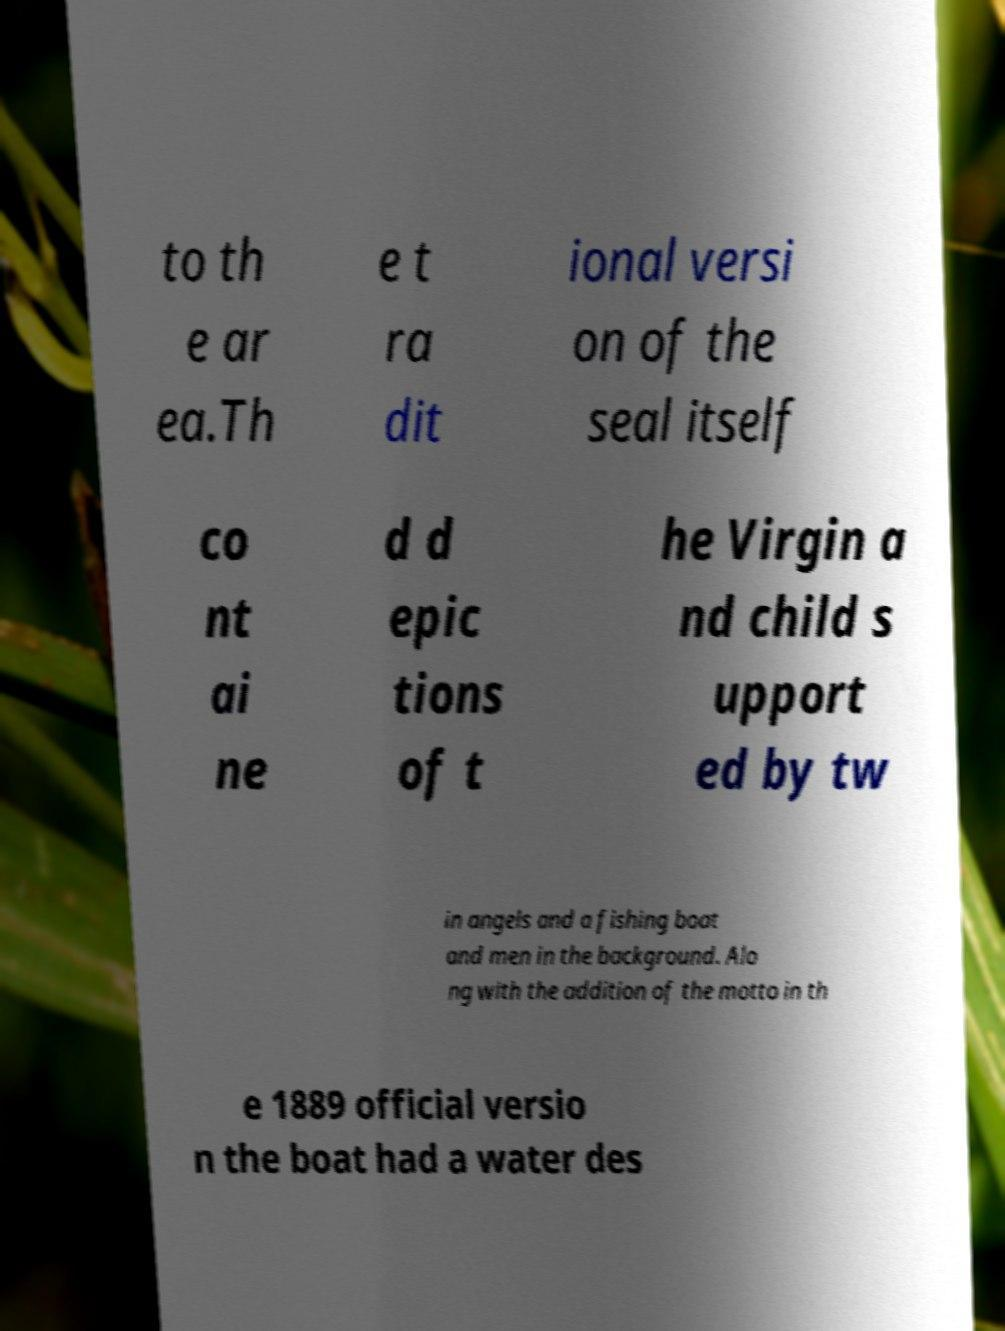Could you assist in decoding the text presented in this image and type it out clearly? to th e ar ea.Th e t ra dit ional versi on of the seal itself co nt ai ne d d epic tions of t he Virgin a nd child s upport ed by tw in angels and a fishing boat and men in the background. Alo ng with the addition of the motto in th e 1889 official versio n the boat had a water des 